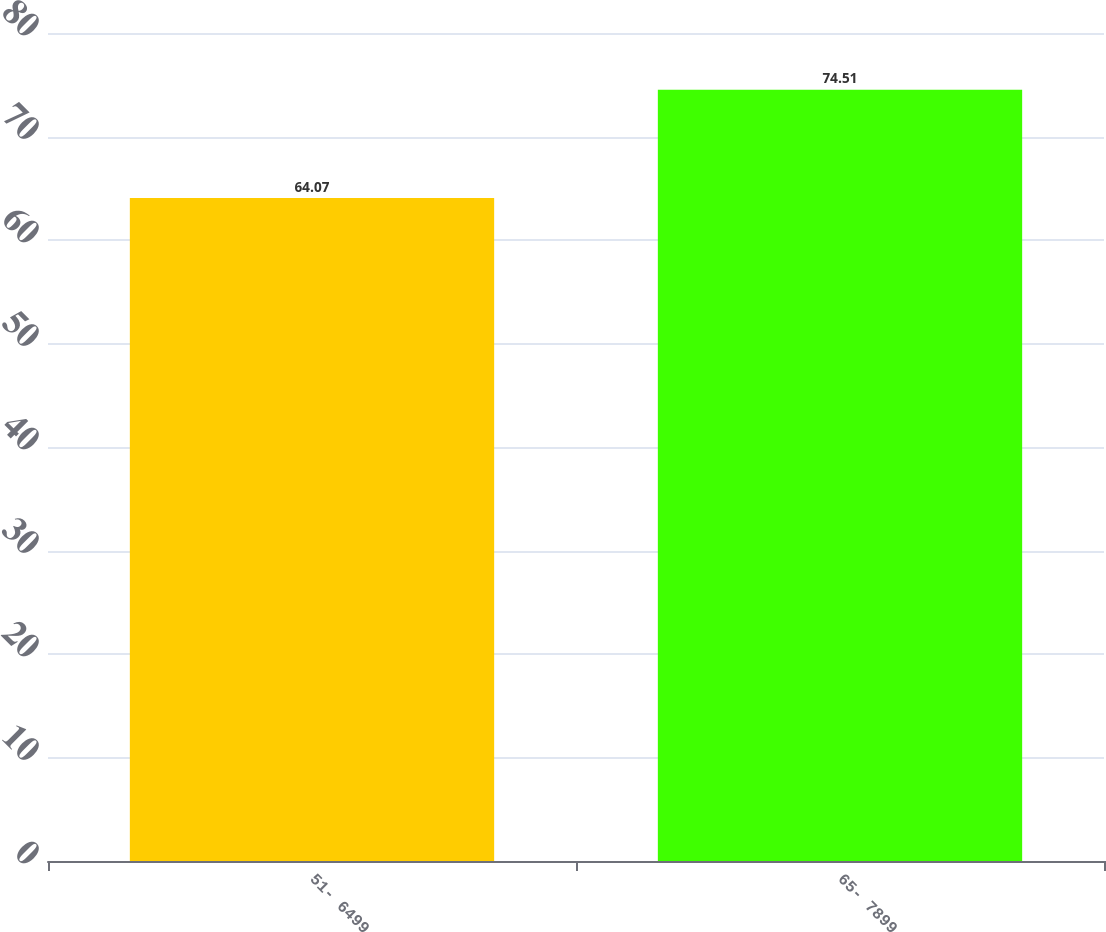Convert chart to OTSL. <chart><loc_0><loc_0><loc_500><loc_500><bar_chart><fcel>51- 6499<fcel>65- 7899<nl><fcel>64.07<fcel>74.51<nl></chart> 